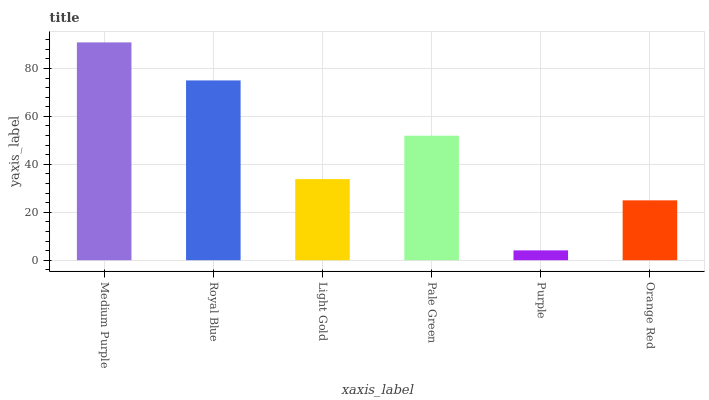Is Medium Purple the maximum?
Answer yes or no. Yes. Is Royal Blue the minimum?
Answer yes or no. No. Is Royal Blue the maximum?
Answer yes or no. No. Is Medium Purple greater than Royal Blue?
Answer yes or no. Yes. Is Royal Blue less than Medium Purple?
Answer yes or no. Yes. Is Royal Blue greater than Medium Purple?
Answer yes or no. No. Is Medium Purple less than Royal Blue?
Answer yes or no. No. Is Pale Green the high median?
Answer yes or no. Yes. Is Light Gold the low median?
Answer yes or no. Yes. Is Light Gold the high median?
Answer yes or no. No. Is Pale Green the low median?
Answer yes or no. No. 